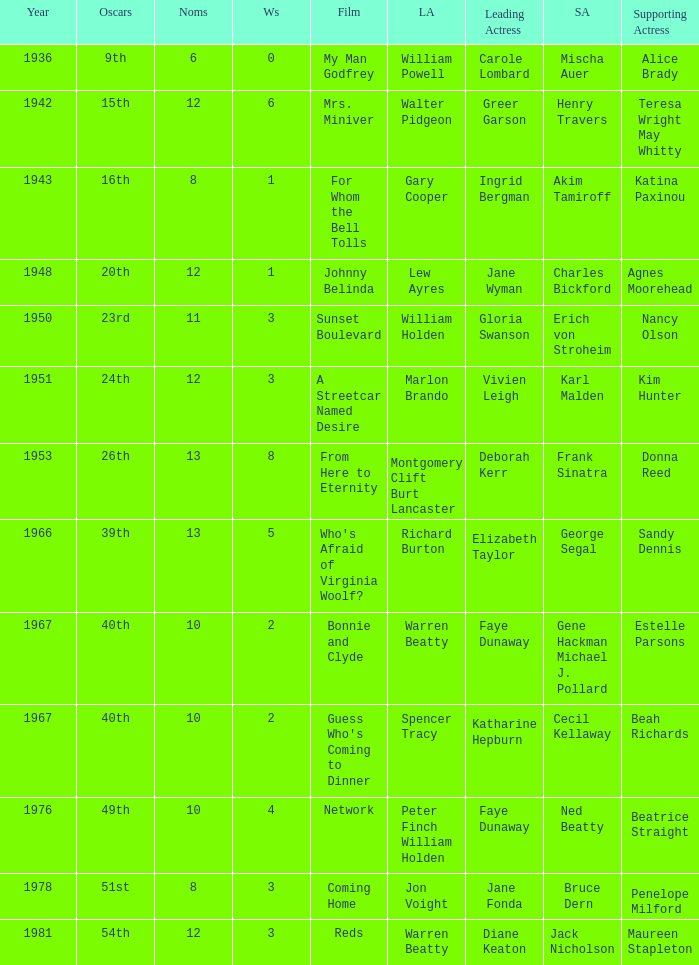Who was the leading actor in the film with a supporting actor named Cecil Kellaway? Spencer Tracy. 